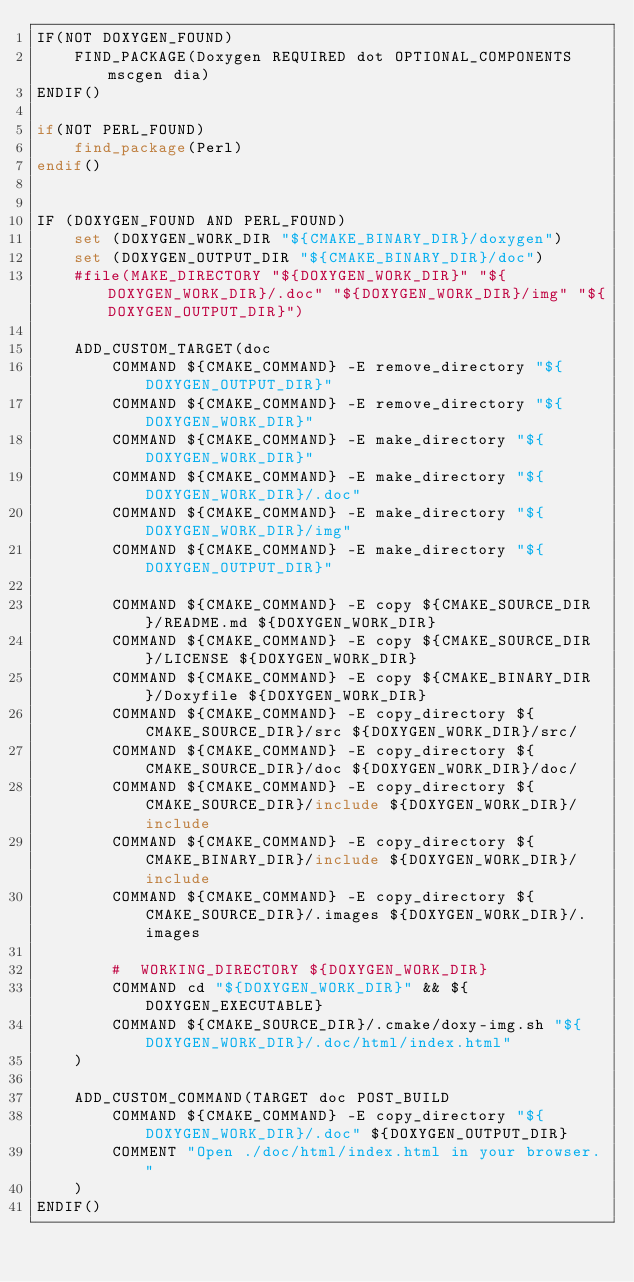Convert code to text. <code><loc_0><loc_0><loc_500><loc_500><_CMake_>IF(NOT DOXYGEN_FOUND)
    FIND_PACKAGE(Doxygen REQUIRED dot OPTIONAL_COMPONENTS mscgen dia)
ENDIF()

if(NOT PERL_FOUND)
	find_package(Perl)
endif()


IF (DOXYGEN_FOUND AND PERL_FOUND)
    set (DOXYGEN_WORK_DIR "${CMAKE_BINARY_DIR}/doxygen")
    set (DOXYGEN_OUTPUT_DIR "${CMAKE_BINARY_DIR}/doc")
    #file(MAKE_DIRECTORY "${DOXYGEN_WORK_DIR}" "${DOXYGEN_WORK_DIR}/.doc" "${DOXYGEN_WORK_DIR}/img" "${DOXYGEN_OUTPUT_DIR}")

    ADD_CUSTOM_TARGET(doc
        COMMAND ${CMAKE_COMMAND} -E remove_directory "${DOXYGEN_OUTPUT_DIR}"
        COMMAND ${CMAKE_COMMAND} -E remove_directory "${DOXYGEN_WORK_DIR}"
        COMMAND ${CMAKE_COMMAND} -E make_directory "${DOXYGEN_WORK_DIR}"
        COMMAND ${CMAKE_COMMAND} -E make_directory "${DOXYGEN_WORK_DIR}/.doc"
        COMMAND ${CMAKE_COMMAND} -E make_directory "${DOXYGEN_WORK_DIR}/img"
        COMMAND ${CMAKE_COMMAND} -E make_directory "${DOXYGEN_OUTPUT_DIR}"

        COMMAND ${CMAKE_COMMAND} -E copy ${CMAKE_SOURCE_DIR}/README.md ${DOXYGEN_WORK_DIR}
        COMMAND ${CMAKE_COMMAND} -E copy ${CMAKE_SOURCE_DIR}/LICENSE ${DOXYGEN_WORK_DIR}
        COMMAND ${CMAKE_COMMAND} -E copy ${CMAKE_BINARY_DIR}/Doxyfile ${DOXYGEN_WORK_DIR}
        COMMAND ${CMAKE_COMMAND} -E copy_directory ${CMAKE_SOURCE_DIR}/src ${DOXYGEN_WORK_DIR}/src/
        COMMAND ${CMAKE_COMMAND} -E copy_directory ${CMAKE_SOURCE_DIR}/doc ${DOXYGEN_WORK_DIR}/doc/
        COMMAND ${CMAKE_COMMAND} -E copy_directory ${CMAKE_SOURCE_DIR}/include ${DOXYGEN_WORK_DIR}/include
        COMMAND ${CMAKE_COMMAND} -E copy_directory ${CMAKE_BINARY_DIR}/include ${DOXYGEN_WORK_DIR}/include
        COMMAND ${CMAKE_COMMAND} -E copy_directory ${CMAKE_SOURCE_DIR}/.images ${DOXYGEN_WORK_DIR}/.images
        
        #  WORKING_DIRECTORY ${DOXYGEN_WORK_DIR}
        COMMAND cd "${DOXYGEN_WORK_DIR}" && ${DOXYGEN_EXECUTABLE}
        COMMAND ${CMAKE_SOURCE_DIR}/.cmake/doxy-img.sh "${DOXYGEN_WORK_DIR}/.doc/html/index.html"
    )
    
    ADD_CUSTOM_COMMAND(TARGET doc POST_BUILD
        COMMAND ${CMAKE_COMMAND} -E copy_directory "${DOXYGEN_WORK_DIR}/.doc" ${DOXYGEN_OUTPUT_DIR}
        COMMENT "Open ./doc/html/index.html in your browser."
    )
ENDIF()
</code> 